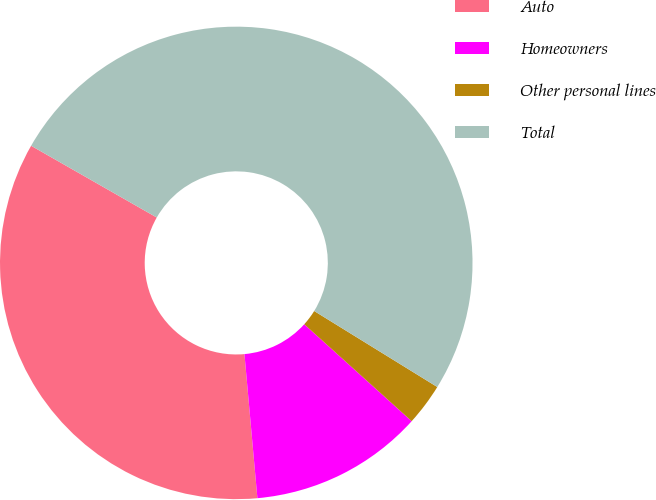Convert chart. <chart><loc_0><loc_0><loc_500><loc_500><pie_chart><fcel>Auto<fcel>Homeowners<fcel>Other personal lines<fcel>Total<nl><fcel>34.68%<fcel>11.89%<fcel>2.88%<fcel>50.54%<nl></chart> 